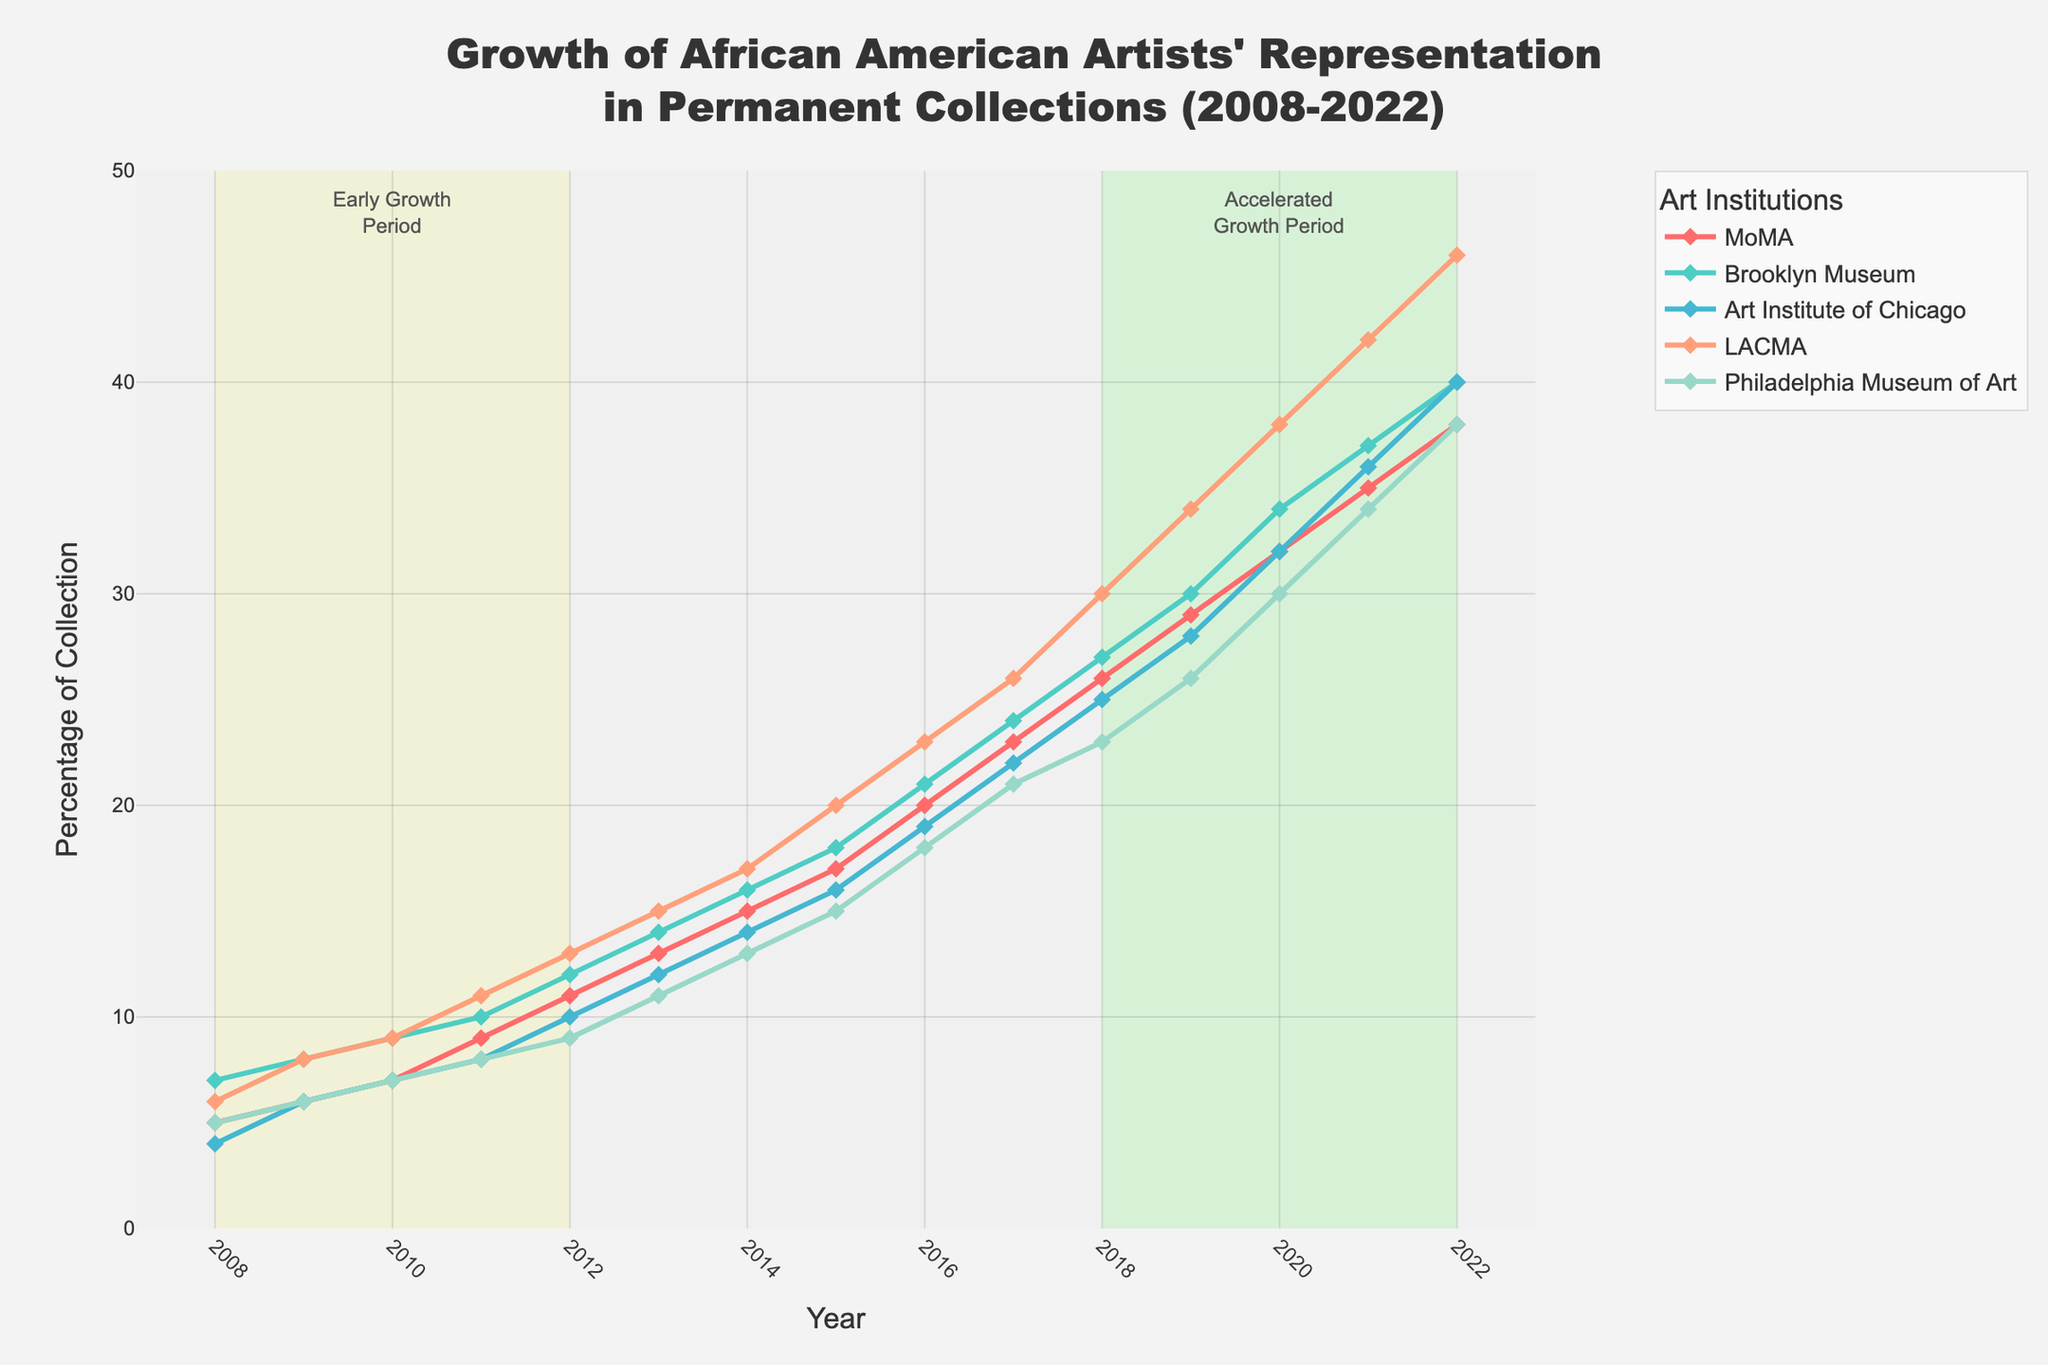what is the title of the figure? The title of the figure is found at the top of the plot and summarizes the main context. By reading this text, we identify the purpose of the plot.
Answer: Growth of African American Artists' Representation in Permanent Collections (2008-2022) Which museum shows the highest representation in 2022? To find the museum with the highest representation in 2022, locate the values for each museum on the y-axis at the year 2022 and compare them.
Answer: LACMA What percentage of the collection did MoMA have in 2010? By looking at the point where MoMA's line intersects the y-axis at the year 2010, we can read the percentage value directly.
Answer: 7% Looking at the entire period from 2008 to 2022, which museum shows the most significant absolute increase in the representation rate? Calculate the difference in percentage points for each museum from 2008 to 2022 by subtracting the 2008 value from the 2022 value, then determine which one is the largest. For MoMA (38-5), Brooklyn Museum (40-7), Art Institute of Chicago (40-4), LACMA (46-6), and Philadelphia Museum of Art (38-5).
Answer: LACMA Which periods are highlighted in the plot? By observing the colored rectangles in the plot, identify the periods they are highlighting. Look for annotations that name these periods.
Answer: 2008-2012 (Early Growth Period) and 2018-2022 (Accelerated Growth Period) During which period did the Philadelphia Museum of Art's representation grow past 10%? Locate the Philadelphia Museum of Art line, follow its trajectory, and identify the year in which it crosses the 10% mark.
Answer: 2012 In what year did LACMA's representation rate first exceed 30%? Trace LACMA's line and observe the year it first surpasses the 30% mark on the y-axis.
Answer: 2018 Comparing MoMA and the Art Institute of Chicago, which museum had a higher rate of representation in 2015? Compare the y-axis values for MoMA and the Art Institute of Chicago at the year 2015 to see which is higher.
Answer: MoMA What is the difference in representation percentage between the Brooklyn Museum and MoMA in 2022? Subtract MoMA’s value from the Brooklyn Museum's value for the year 2022. Brooklyn Museum (40) and MoMA (38).
Answer: 2% What is the average representation percentage of LACMA over the highlighted "Accelerated Growth Period"? Calculate the average of LACMA’s values from 2018 to 2022: (30+34+38+42+46)/5. Total = 190, and 190/5.
Answer: 38% 